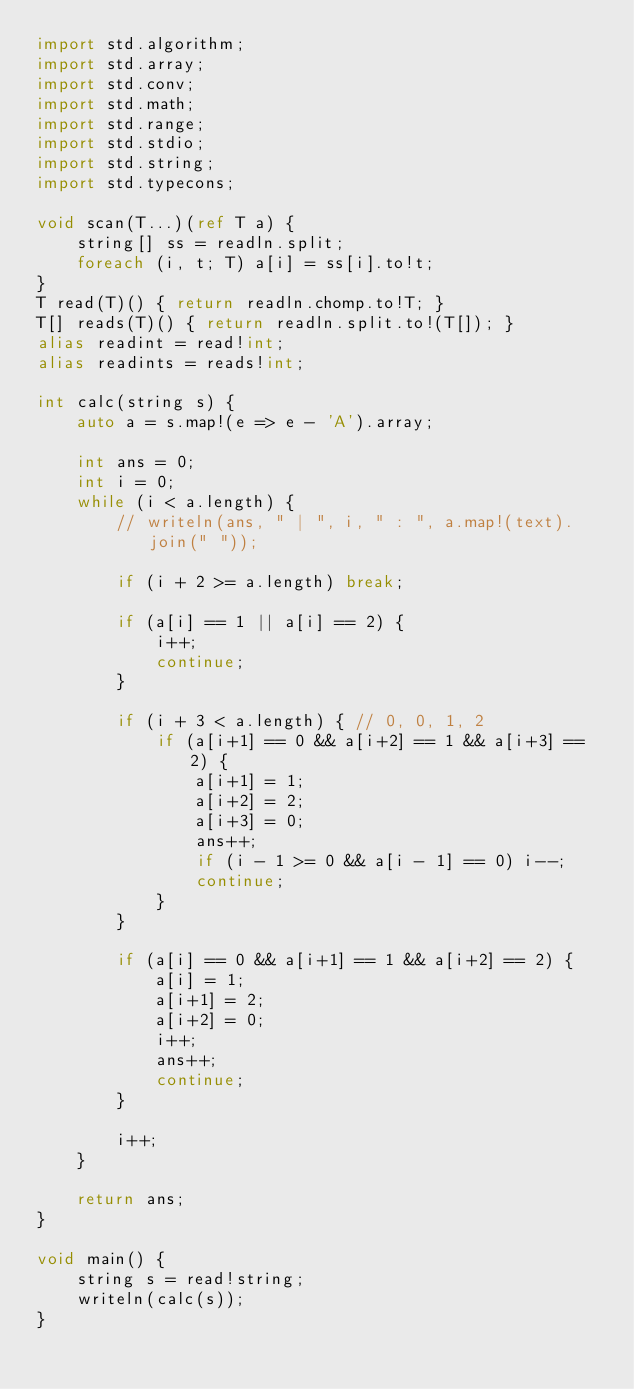<code> <loc_0><loc_0><loc_500><loc_500><_D_>import std.algorithm;
import std.array;
import std.conv;
import std.math;
import std.range;
import std.stdio;
import std.string;
import std.typecons;

void scan(T...)(ref T a) {
    string[] ss = readln.split;
    foreach (i, t; T) a[i] = ss[i].to!t;
}
T read(T)() { return readln.chomp.to!T; }
T[] reads(T)() { return readln.split.to!(T[]); }
alias readint = read!int;
alias readints = reads!int;

int calc(string s) {
    auto a = s.map!(e => e - 'A').array;

    int ans = 0;
    int i = 0;
    while (i < a.length) {
        // writeln(ans, " | ", i, " : ", a.map!(text).join(" "));

        if (i + 2 >= a.length) break;

        if (a[i] == 1 || a[i] == 2) {
            i++;
            continue;
        }

        if (i + 3 < a.length) { // 0, 0, 1, 2
            if (a[i+1] == 0 && a[i+2] == 1 && a[i+3] == 2) {
                a[i+1] = 1;
                a[i+2] = 2;
                a[i+3] = 0;
                ans++;
                if (i - 1 >= 0 && a[i - 1] == 0) i--;
                continue;
            }
        }

        if (a[i] == 0 && a[i+1] == 1 && a[i+2] == 2) {
            a[i] = 1;
            a[i+1] = 2;
            a[i+2] = 0;
            i++;
            ans++;
            continue;
        }

        i++;
    }

    return ans;
}

void main() {
    string s = read!string;
    writeln(calc(s));
}
</code> 